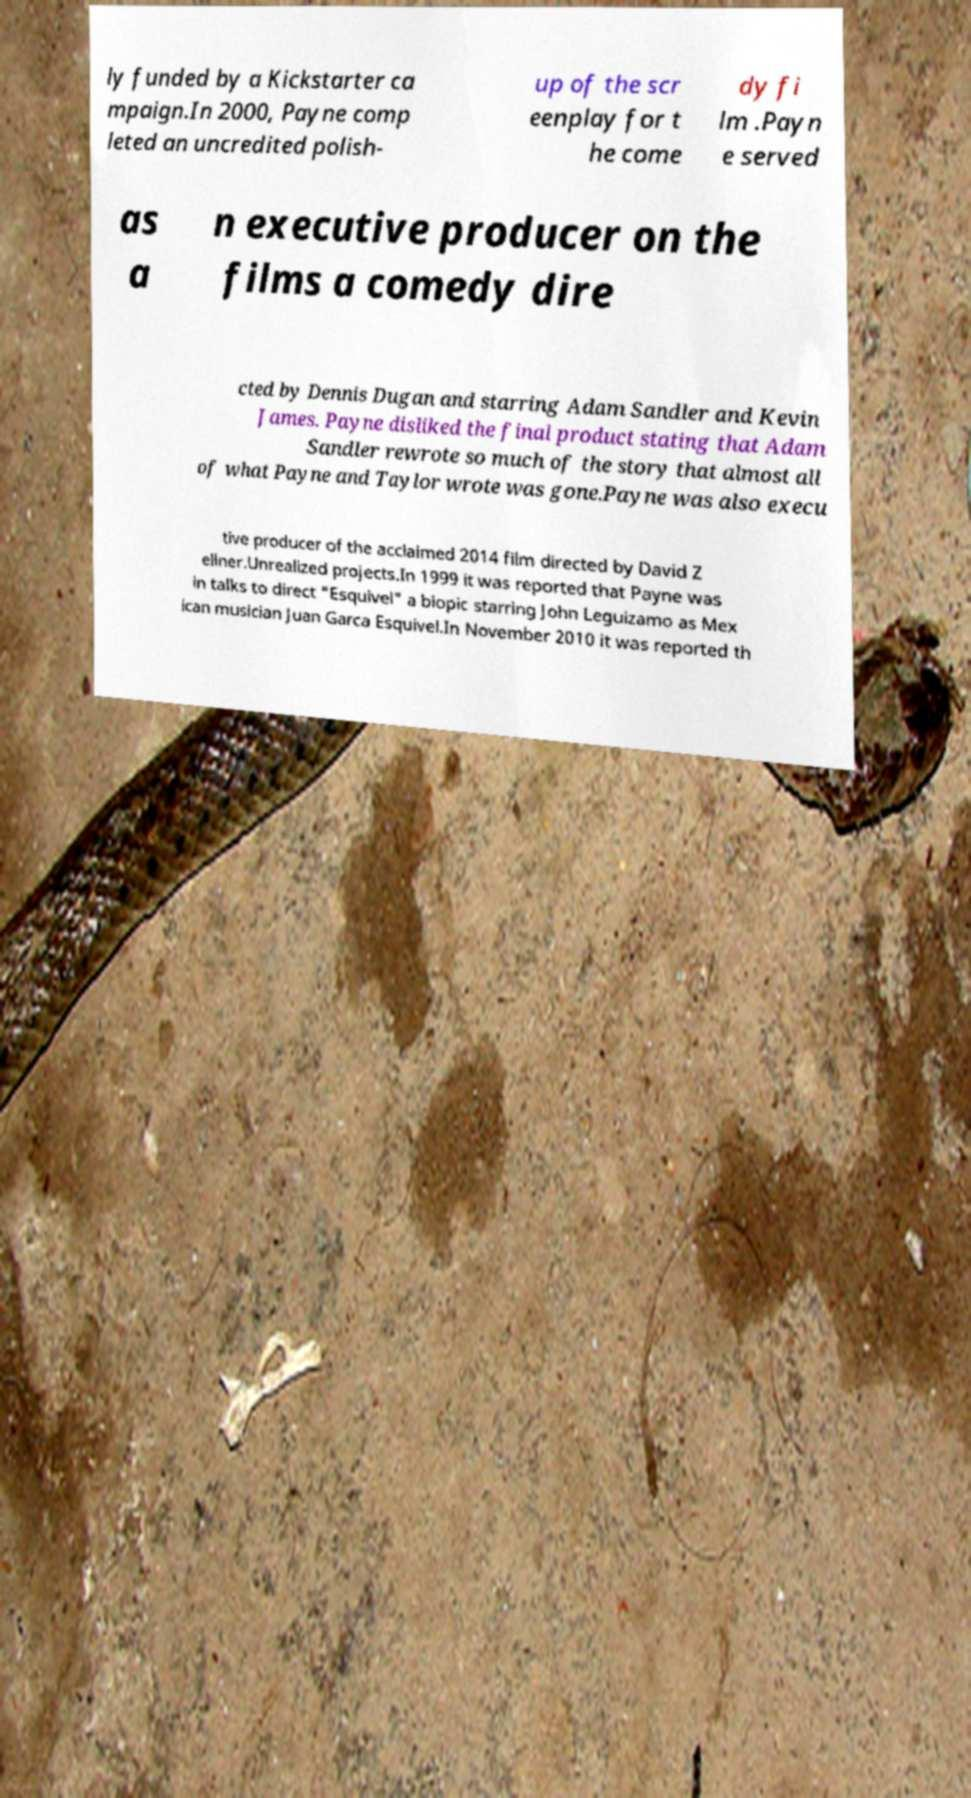Please read and relay the text visible in this image. What does it say? ly funded by a Kickstarter ca mpaign.In 2000, Payne comp leted an uncredited polish- up of the scr eenplay for t he come dy fi lm .Payn e served as a n executive producer on the films a comedy dire cted by Dennis Dugan and starring Adam Sandler and Kevin James. Payne disliked the final product stating that Adam Sandler rewrote so much of the story that almost all of what Payne and Taylor wrote was gone.Payne was also execu tive producer of the acclaimed 2014 film directed by David Z ellner.Unrealized projects.In 1999 it was reported that Payne was in talks to direct "Esquivel" a biopic starring John Leguizamo as Mex ican musician Juan Garca Esquivel.In November 2010 it was reported th 